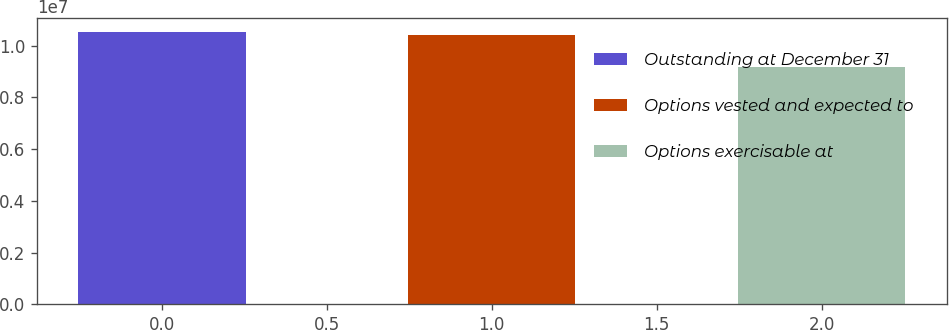Convert chart. <chart><loc_0><loc_0><loc_500><loc_500><bar_chart><fcel>Outstanding at December 31<fcel>Options vested and expected to<fcel>Options exercisable at<nl><fcel>1.0519e+07<fcel>1.03951e+07<fcel>9.1627e+06<nl></chart> 